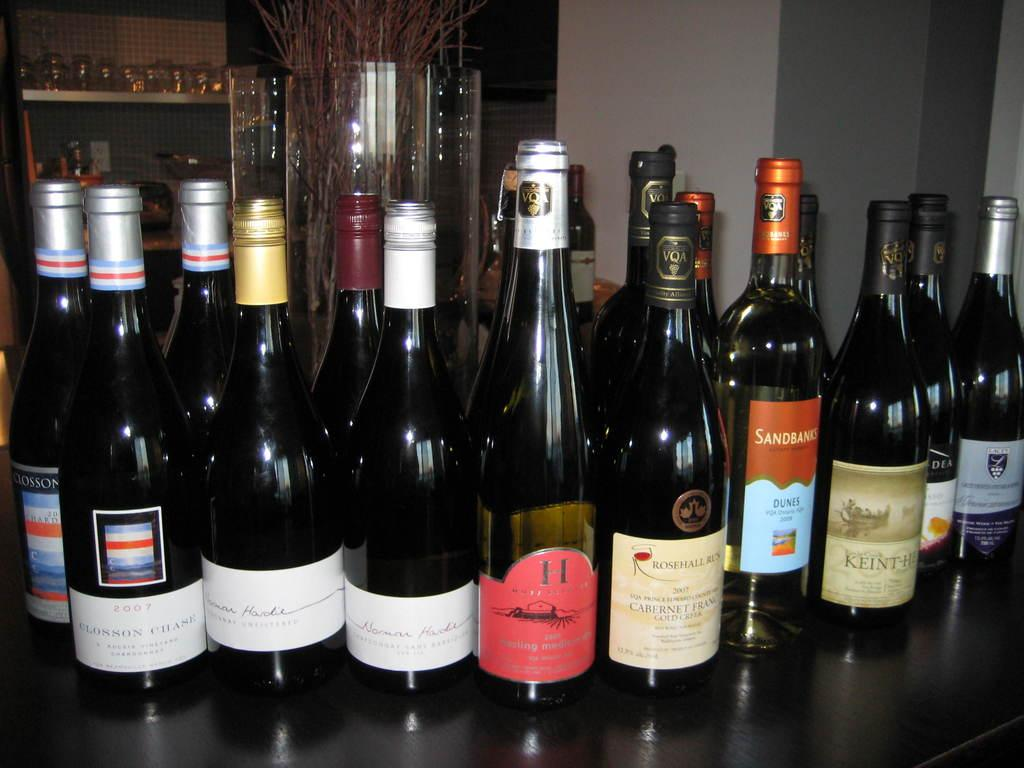Provide a one-sentence caption for the provided image. bottles of wined on a bar include Rose Hall and Dunes. 